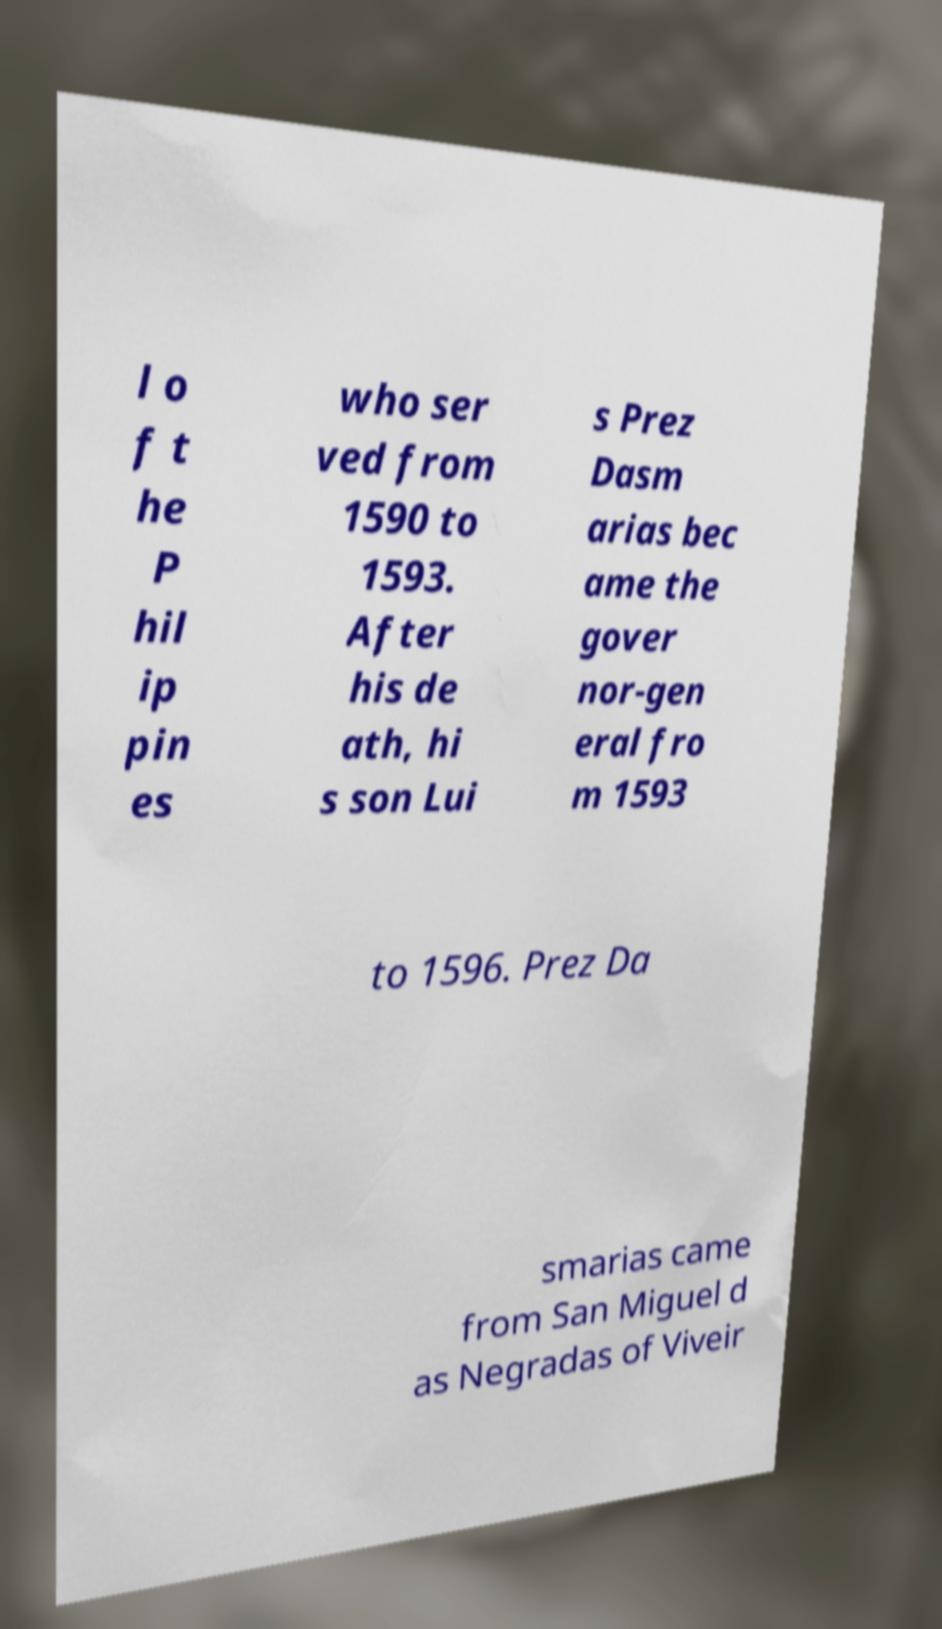Please read and relay the text visible in this image. What does it say? l o f t he P hil ip pin es who ser ved from 1590 to 1593. After his de ath, hi s son Lui s Prez Dasm arias bec ame the gover nor-gen eral fro m 1593 to 1596. Prez Da smarias came from San Miguel d as Negradas of Viveir 